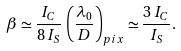<formula> <loc_0><loc_0><loc_500><loc_500>\beta \simeq \frac { I _ { C } } { 8 \, I _ { S } } \, \left ( \frac { \lambda _ { 0 } } { D } \right ) _ { p i x } \simeq \frac { 3 \, I _ { C } } { I _ { S } } .</formula> 